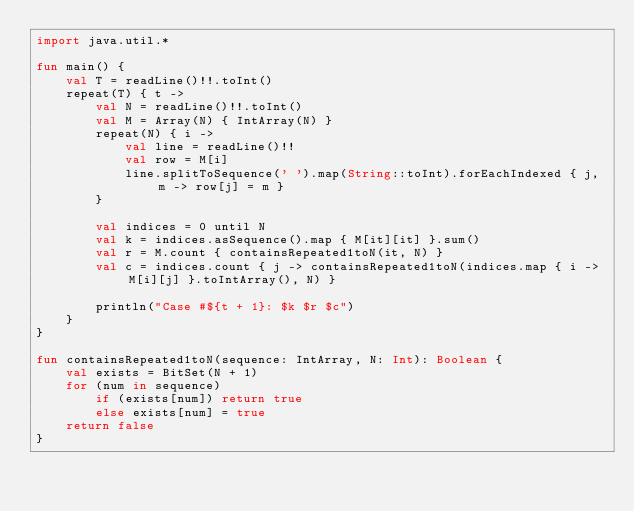Convert code to text. <code><loc_0><loc_0><loc_500><loc_500><_Kotlin_>import java.util.*

fun main() {
    val T = readLine()!!.toInt()
    repeat(T) { t ->
        val N = readLine()!!.toInt()
        val M = Array(N) { IntArray(N) }
        repeat(N) { i ->
            val line = readLine()!!
            val row = M[i]
            line.splitToSequence(' ').map(String::toInt).forEachIndexed { j, m -> row[j] = m }
        }

        val indices = 0 until N
        val k = indices.asSequence().map { M[it][it] }.sum()
        val r = M.count { containsRepeated1toN(it, N) }
        val c = indices.count { j -> containsRepeated1toN(indices.map { i -> M[i][j] }.toIntArray(), N) }

        println("Case #${t + 1}: $k $r $c")
    }
}

fun containsRepeated1toN(sequence: IntArray, N: Int): Boolean {
    val exists = BitSet(N + 1)
    for (num in sequence)
        if (exists[num]) return true
        else exists[num] = true
    return false
}</code> 